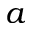Convert formula to latex. <formula><loc_0><loc_0><loc_500><loc_500>a</formula> 